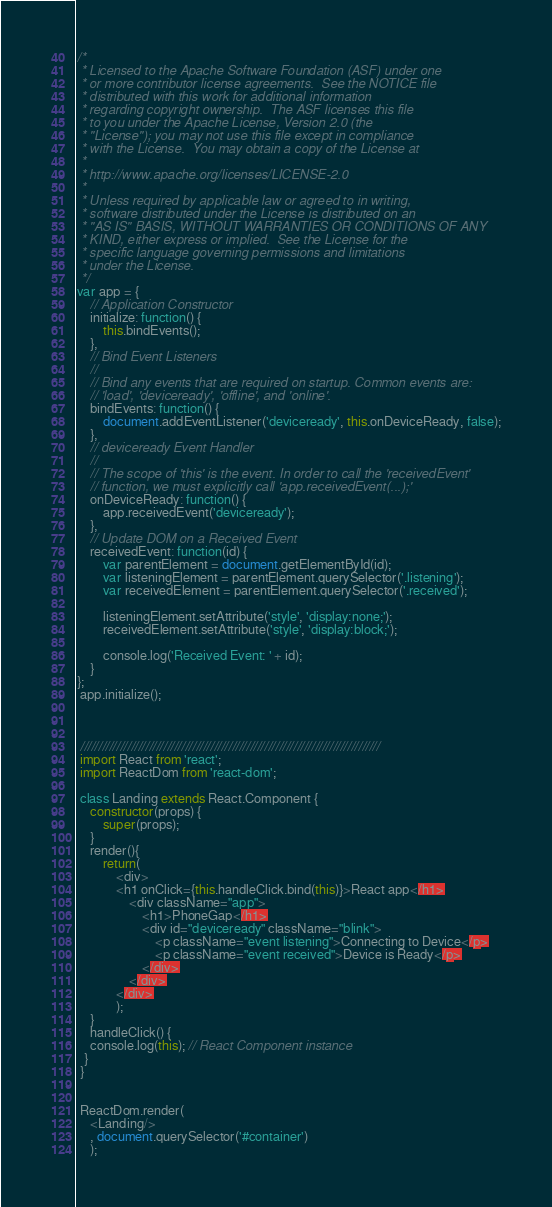Convert code to text. <code><loc_0><loc_0><loc_500><loc_500><_JavaScript_>/*
 * Licensed to the Apache Software Foundation (ASF) under one
 * or more contributor license agreements.  See the NOTICE file
 * distributed with this work for additional information
 * regarding copyright ownership.  The ASF licenses this file
 * to you under the Apache License, Version 2.0 (the
 * "License"); you may not use this file except in compliance
 * with the License.  You may obtain a copy of the License at
 *
 * http://www.apache.org/licenses/LICENSE-2.0
 *
 * Unless required by applicable law or agreed to in writing,
 * software distributed under the License is distributed on an
 * "AS IS" BASIS, WITHOUT WARRANTIES OR CONDITIONS OF ANY
 * KIND, either express or implied.  See the License for the
 * specific language governing permissions and limitations
 * under the License.
 */
var app = {
    // Application Constructor
    initialize: function() {
        this.bindEvents();
    },
    // Bind Event Listeners
    //
    // Bind any events that are required on startup. Common events are:
    // 'load', 'deviceready', 'offline', and 'online'.
    bindEvents: function() {
        document.addEventListener('deviceready', this.onDeviceReady, false);
    },
    // deviceready Event Handler
    //
    // The scope of 'this' is the event. In order to call the 'receivedEvent'
    // function, we must explicitly call 'app.receivedEvent(...);'
    onDeviceReady: function() {
        app.receivedEvent('deviceready');
    },
    // Update DOM on a Received Event
    receivedEvent: function(id) {
        var parentElement = document.getElementById(id);
        var listeningElement = parentElement.querySelector('.listening');
        var receivedElement = parentElement.querySelector('.received');

        listeningElement.setAttribute('style', 'display:none;');
        receivedElement.setAttribute('style', 'display:block;');

        console.log('Received Event: ' + id);
    }
};
 app.initialize();



 ///////////////////////////////////////////////////////////////////////////////////
 import React from 'react';
 import ReactDom from 'react-dom';

 class Landing extends React.Component {
    constructor(props) {
        super(props);
    }
    render(){
        return(
            <div>
            <h1 onClick={this.handleClick.bind(this)}>React app</h1>
                <div className="app">
                    <h1>PhoneGap</h1>
                    <div id="deviceready" className="blink">
                        <p className="event listening">Connecting to Device</p>
                        <p className="event received">Device is Ready</p>
                    </div>
                </div>
            </div>
            );
    }
    handleClick() {
    console.log(this); // React Component instance
  }
 }


 ReactDom.render(
    <Landing/>
    , document.querySelector('#container')
    );</code> 